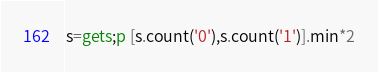<code> <loc_0><loc_0><loc_500><loc_500><_Ruby_>s=gets;p [s.count('0'),s.count('1')].min*2</code> 